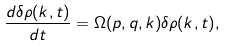<formula> <loc_0><loc_0><loc_500><loc_500>\frac { d \delta { \rho ( { k } , t ) } } { d t } = \Omega ( p , q , { k } ) \delta { \rho ( { k } , t ) } ,</formula> 